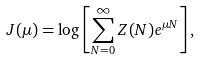<formula> <loc_0><loc_0><loc_500><loc_500>J ( \mu ) = \log \left [ \sum _ { N = 0 } ^ { \infty } Z ( N ) e ^ { \mu N } \right ] ,</formula> 